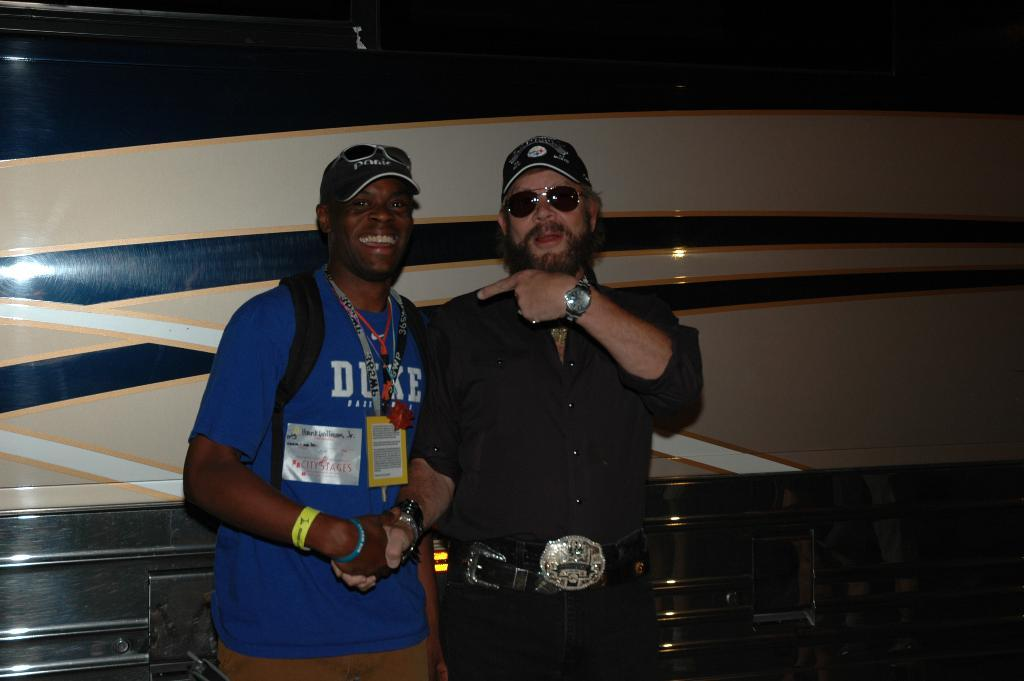How many people are in the image? There are two people in the image. What are the people wearing on their heads? Both people are wearing caps. What color is the dress of the person on the left? The person on the left is wearing a blue dress. What color is the dress of the person on the right? The person on the right is wearing a black dress. What type of eyewear are the people wearing? Both people are wearing goggles. What can be seen in the background of the image? There is a wall visible in the background of the image. What is the income of the person on the right in the image? There is no information about the income of the person in the image. How long does it take for the person on the left to pay attention in the image? There is no information about the person's attention span in the image. 